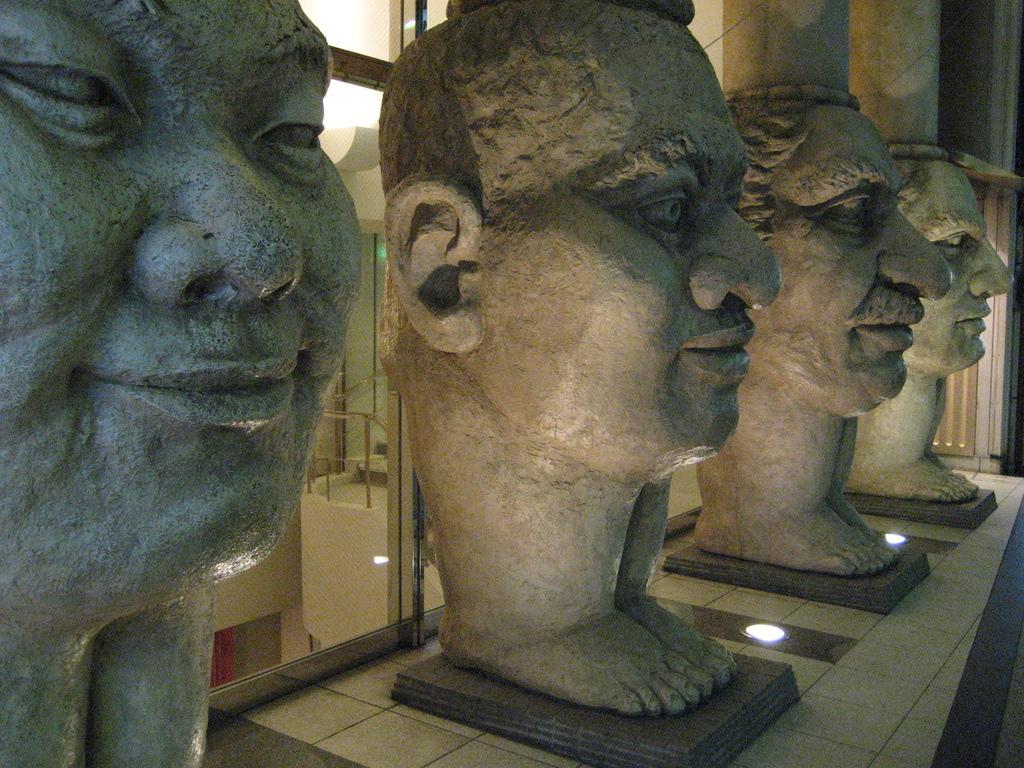In one or two sentences, can you explain what this image depicts? There are sculptures on a platform on the wall and there are lights on the floor and behind them there are glass doors. Through the glass doors we can see wall and metal objects. 